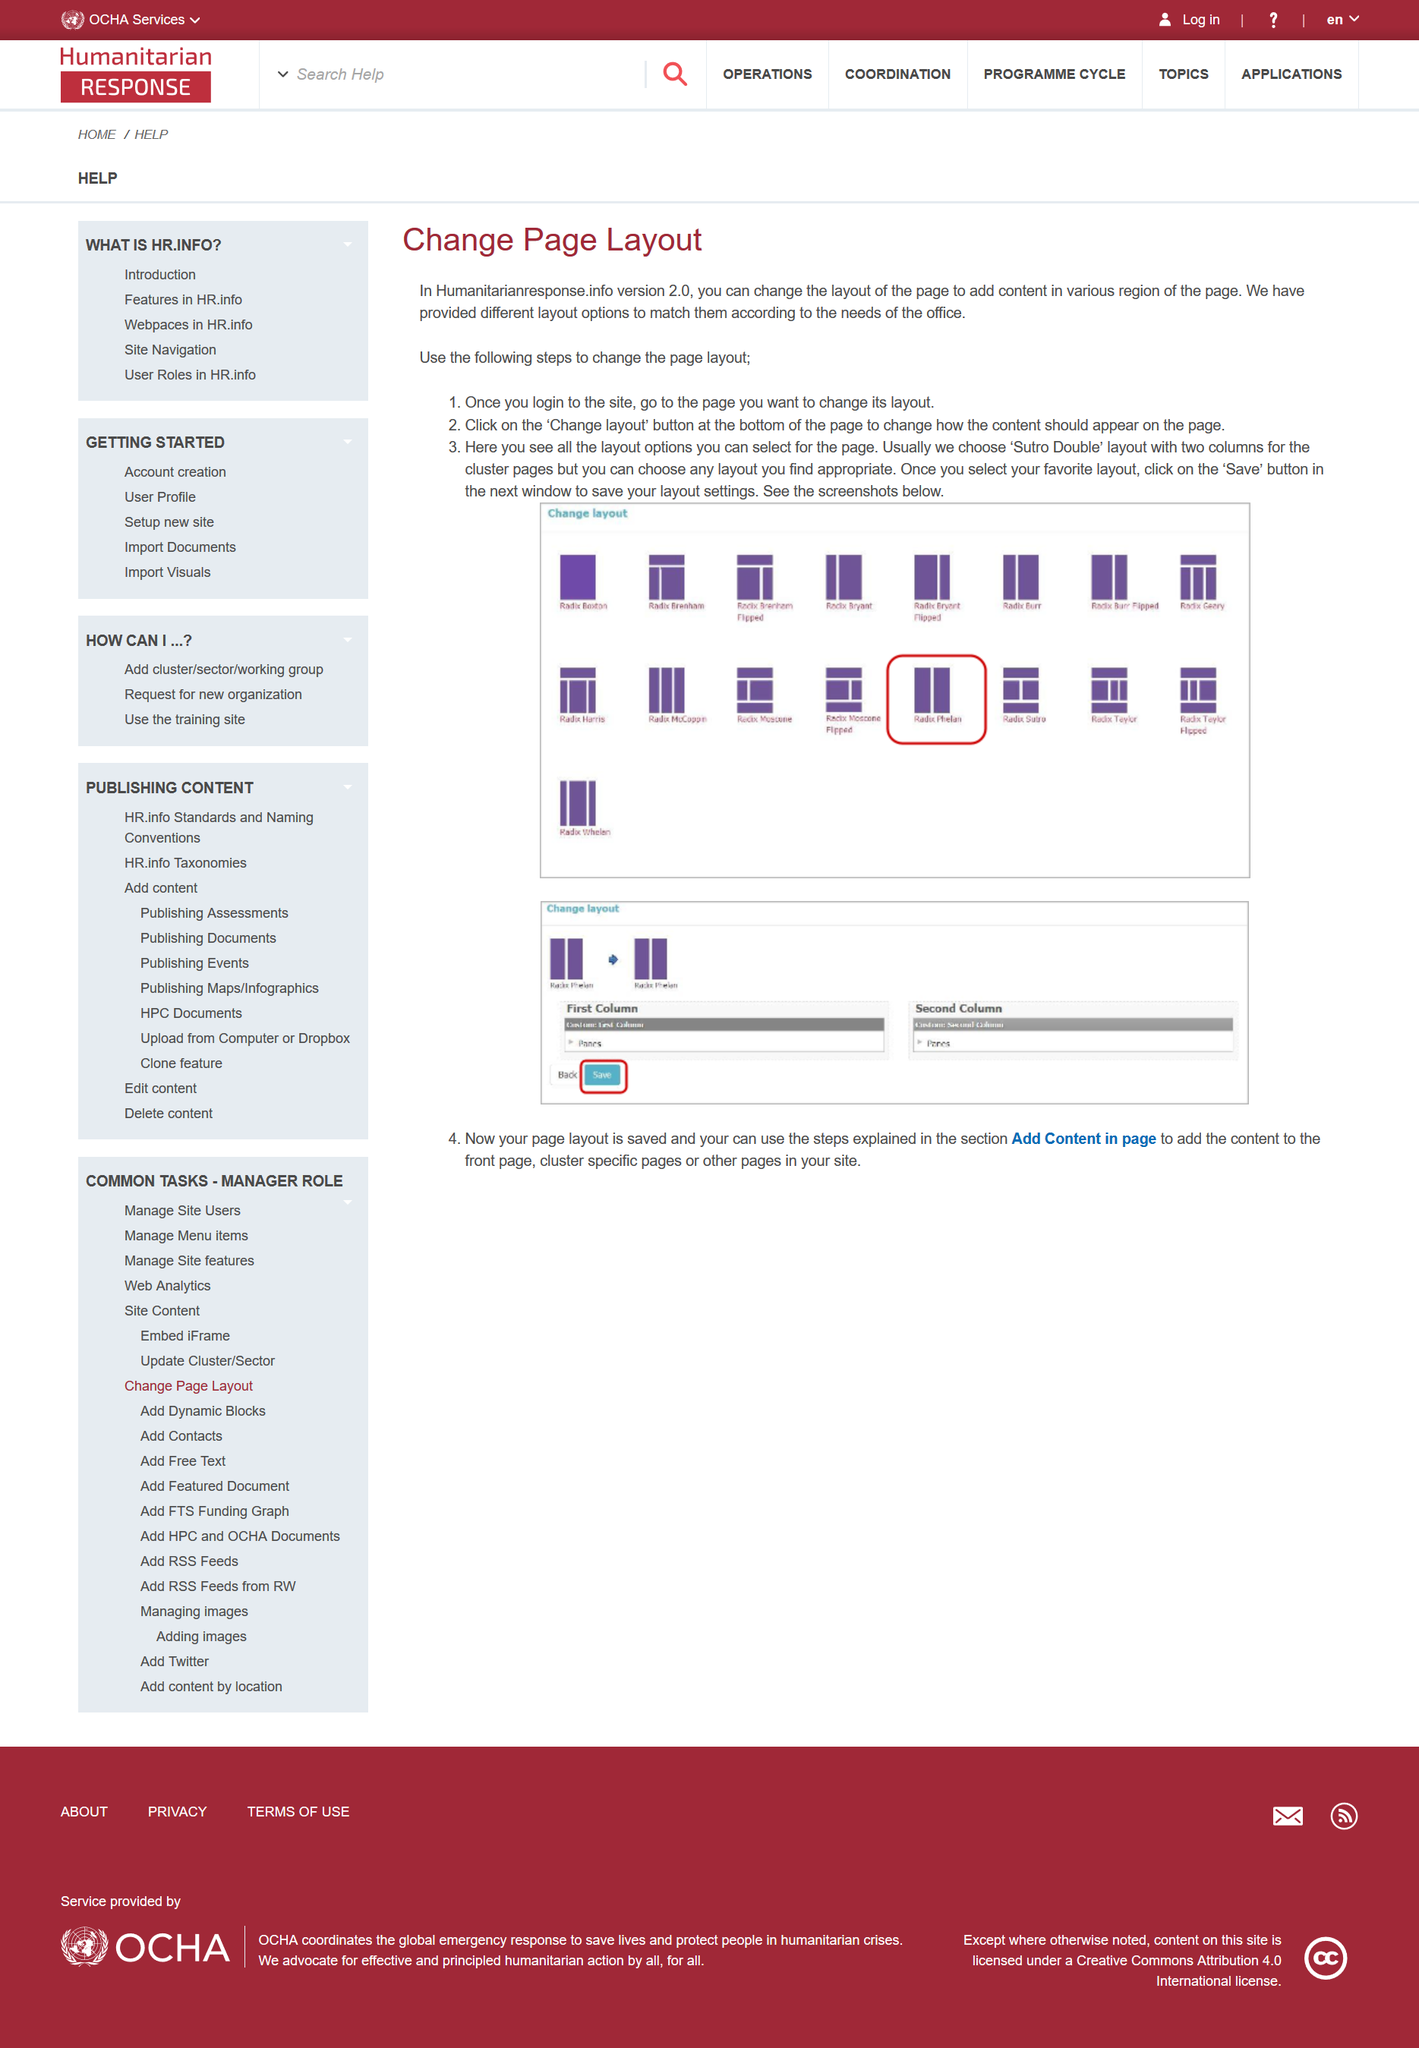Identify some key points in this picture. The image depicts version 2.0 of Humanitarianresponse.info. Humanitarianresponse.info version 2.0 provides 17 different page layout options. The page layout known as 'Sutro Double' is included in Humanitarianresponse.info version 2.0. 